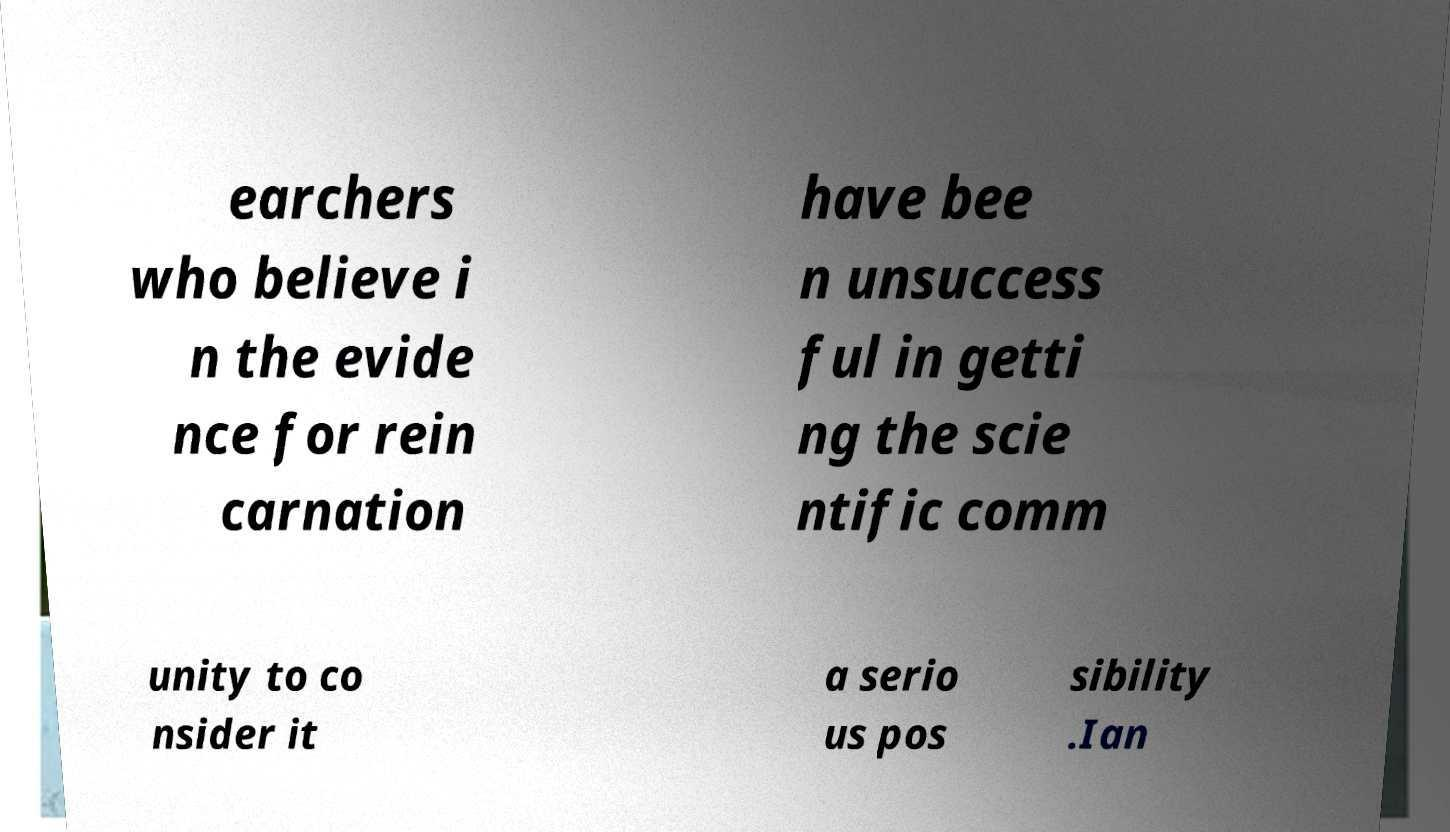Could you assist in decoding the text presented in this image and type it out clearly? earchers who believe i n the evide nce for rein carnation have bee n unsuccess ful in getti ng the scie ntific comm unity to co nsider it a serio us pos sibility .Ian 